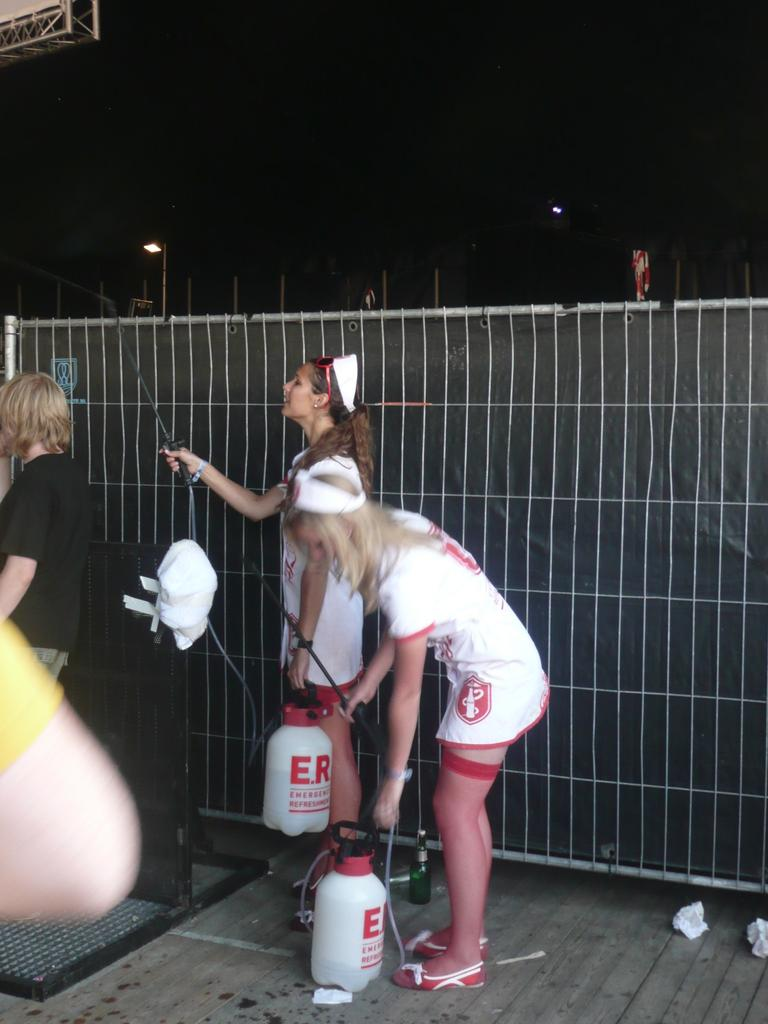<image>
Offer a succinct explanation of the picture presented. A woman in a nurse outfit carries a tank that says E.R. on it. 